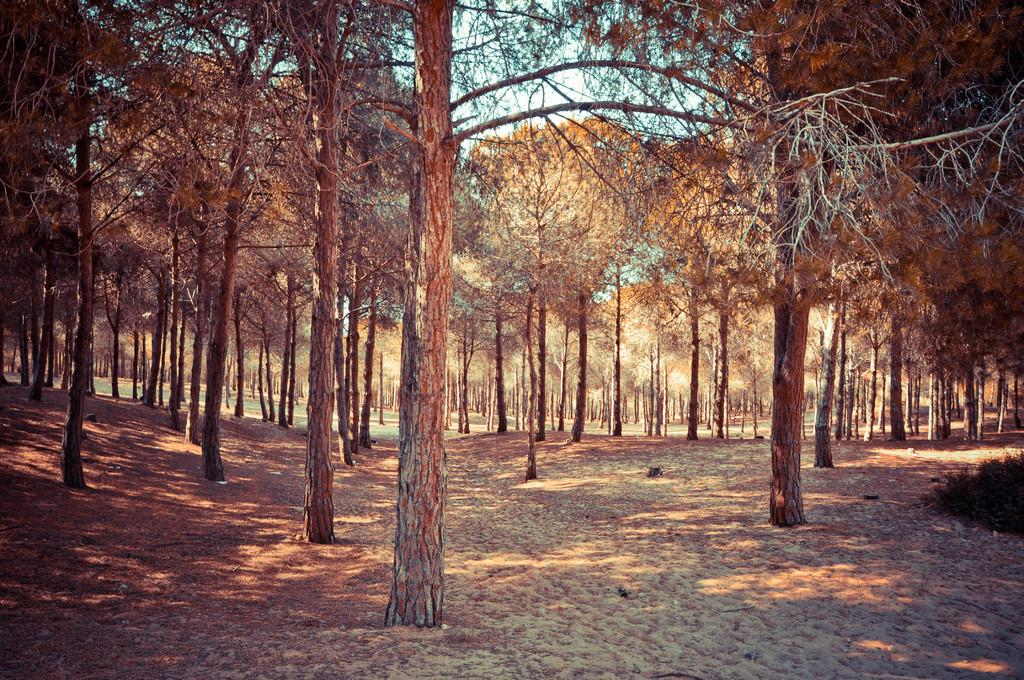What is located in the center of the image? There are trees in the center of the image. What type of surface is visible at the bottom of the image? There is ground visible at the bottom of the image. Can you see any frogs driving a car in the image? There are no frogs or cars present in the image. 